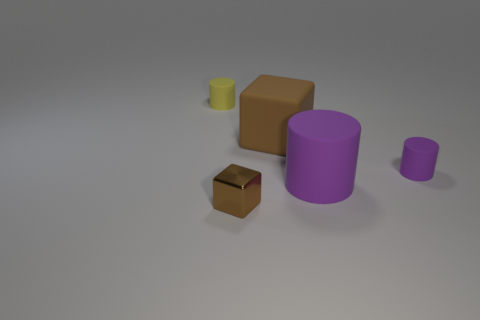Subtract all tiny yellow cylinders. How many cylinders are left? 2 Subtract all yellow cylinders. How many cylinders are left? 2 Subtract all cylinders. How many objects are left? 2 Add 3 brown rubber objects. How many objects exist? 8 Subtract 2 blocks. How many blocks are left? 0 Subtract all green cylinders. How many blue cubes are left? 0 Add 2 small yellow things. How many small yellow things are left? 3 Add 4 tiny brown things. How many tiny brown things exist? 5 Subtract 1 yellow cylinders. How many objects are left? 4 Subtract all gray cylinders. Subtract all purple spheres. How many cylinders are left? 3 